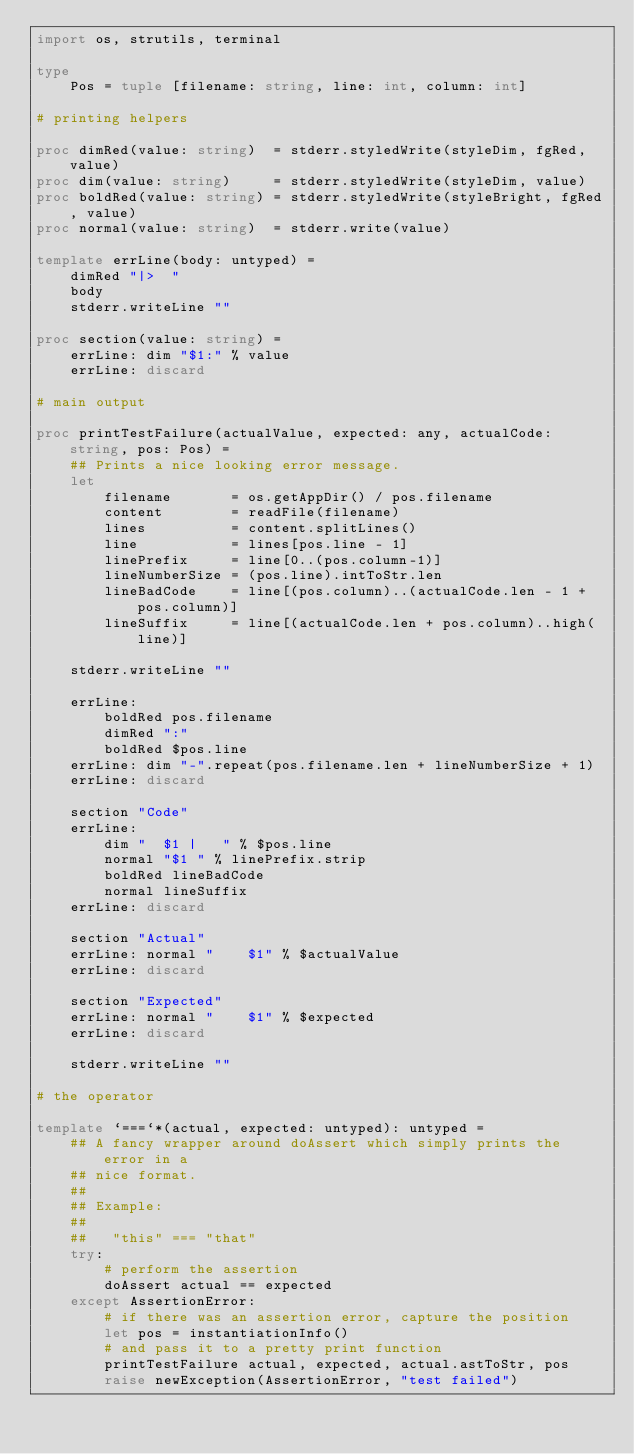Convert code to text. <code><loc_0><loc_0><loc_500><loc_500><_Nim_>import os, strutils, terminal

type
    Pos = tuple [filename: string, line: int, column: int]

# printing helpers

proc dimRed(value: string)  = stderr.styledWrite(styleDim, fgRed, value)
proc dim(value: string)     = stderr.styledWrite(styleDim, value)
proc boldRed(value: string) = stderr.styledWrite(styleBright, fgRed, value)
proc normal(value: string)  = stderr.write(value)

template errLine(body: untyped) =
    dimRed "|>  "
    body
    stderr.writeLine ""

proc section(value: string) =
    errLine: dim "$1:" % value
    errLine: discard

# main output

proc printTestFailure(actualValue, expected: any, actualCode: string, pos: Pos) =
    ## Prints a nice looking error message.
    let
        filename       = os.getAppDir() / pos.filename
        content        = readFile(filename)
        lines          = content.splitLines()
        line           = lines[pos.line - 1]
        linePrefix     = line[0..(pos.column-1)]
        lineNumberSize = (pos.line).intToStr.len
        lineBadCode    = line[(pos.column)..(actualCode.len - 1 + pos.column)]
        lineSuffix     = line[(actualCode.len + pos.column)..high(line)]

    stderr.writeLine ""

    errLine:
        boldRed pos.filename
        dimRed ":"
        boldRed $pos.line
    errLine: dim "-".repeat(pos.filename.len + lineNumberSize + 1)
    errLine: discard

    section "Code"
    errLine:
        dim "  $1 |   " % $pos.line
        normal "$1 " % linePrefix.strip
        boldRed lineBadCode
        normal lineSuffix
    errLine: discard

    section "Actual"
    errLine: normal "    $1" % $actualValue
    errLine: discard

    section "Expected"
    errLine: normal "    $1" % $expected
    errLine: discard

    stderr.writeLine ""

# the operator

template `===`*(actual, expected: untyped): untyped =
    ## A fancy wrapper around doAssert which simply prints the error in a
    ## nice format.
    ## 
    ## Example:
    ##
    ##   "this" === "that"
    try:
        # perform the assertion
        doAssert actual == expected
    except AssertionError:
        # if there was an assertion error, capture the position
        let pos = instantiationInfo()
        # and pass it to a pretty print function
        printTestFailure actual, expected, actual.astToStr, pos
        raise newException(AssertionError, "test failed")
</code> 